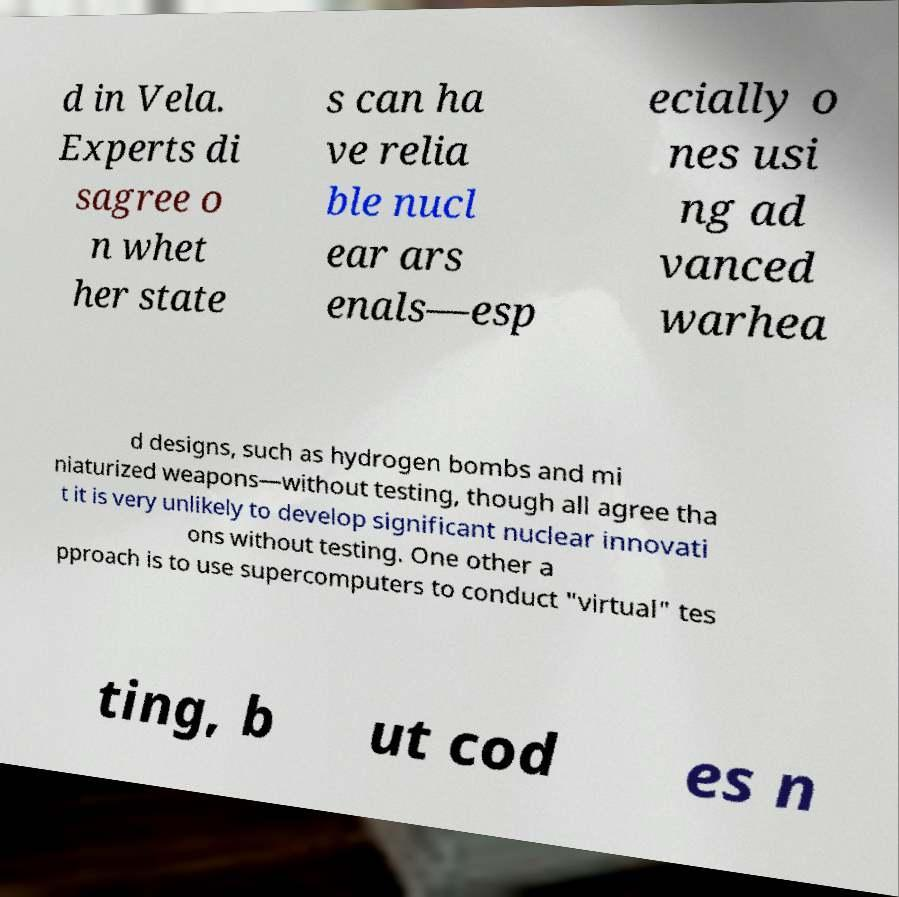Could you extract and type out the text from this image? d in Vela. Experts di sagree o n whet her state s can ha ve relia ble nucl ear ars enals—esp ecially o nes usi ng ad vanced warhea d designs, such as hydrogen bombs and mi niaturized weapons—without testing, though all agree tha t it is very unlikely to develop significant nuclear innovati ons without testing. One other a pproach is to use supercomputers to conduct "virtual" tes ting, b ut cod es n 